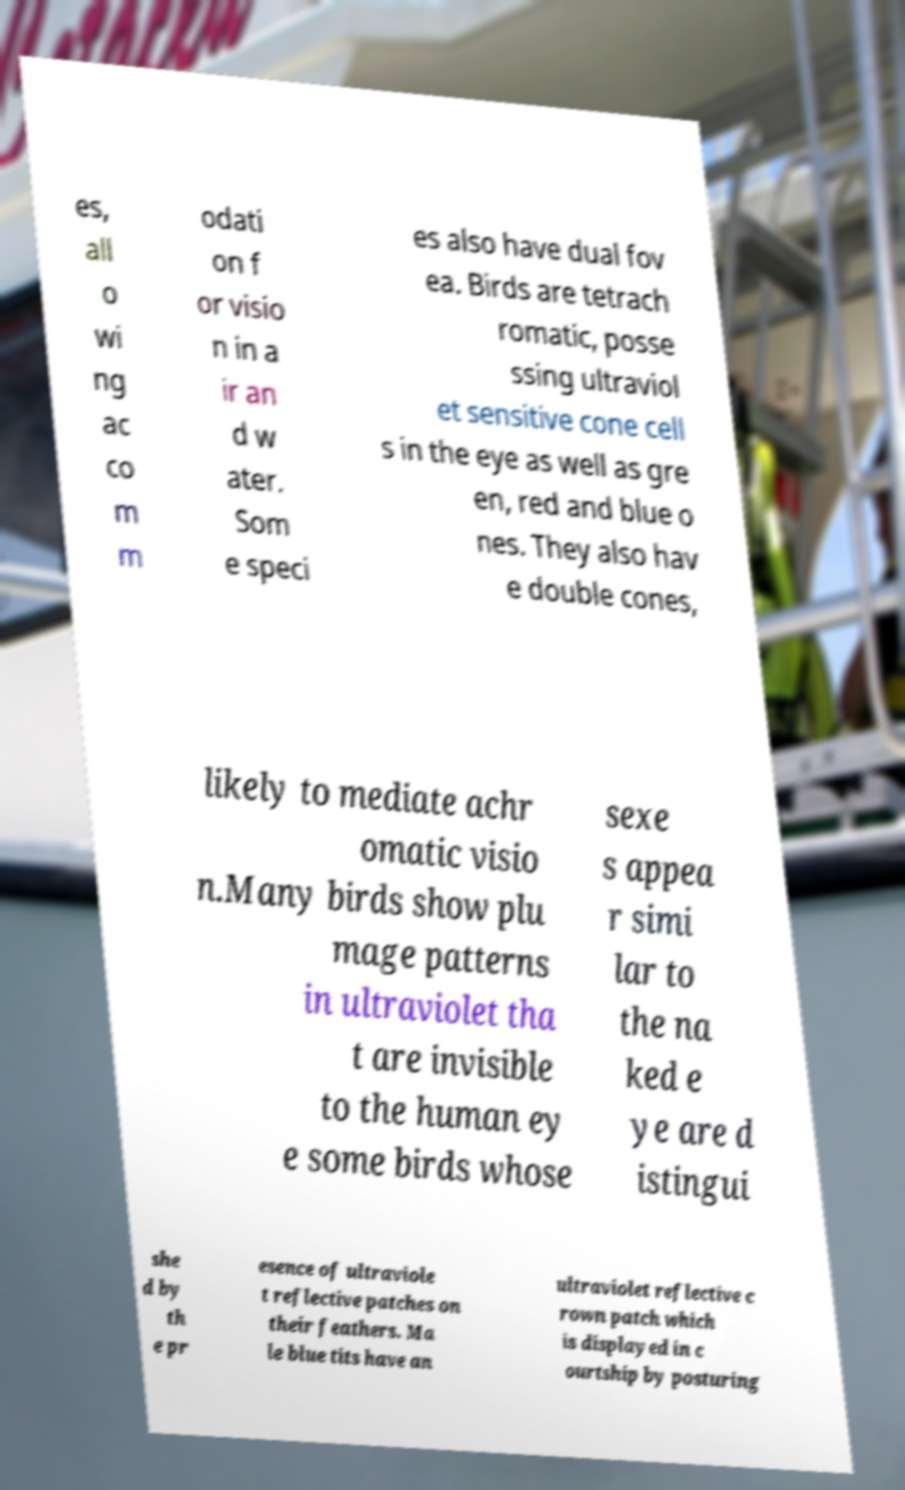Please read and relay the text visible in this image. What does it say? es, all o wi ng ac co m m odati on f or visio n in a ir an d w ater. Som e speci es also have dual fov ea. Birds are tetrach romatic, posse ssing ultraviol et sensitive cone cell s in the eye as well as gre en, red and blue o nes. They also hav e double cones, likely to mediate achr omatic visio n.Many birds show plu mage patterns in ultraviolet tha t are invisible to the human ey e some birds whose sexe s appea r simi lar to the na ked e ye are d istingui she d by th e pr esence of ultraviole t reflective patches on their feathers. Ma le blue tits have an ultraviolet reflective c rown patch which is displayed in c ourtship by posturing 